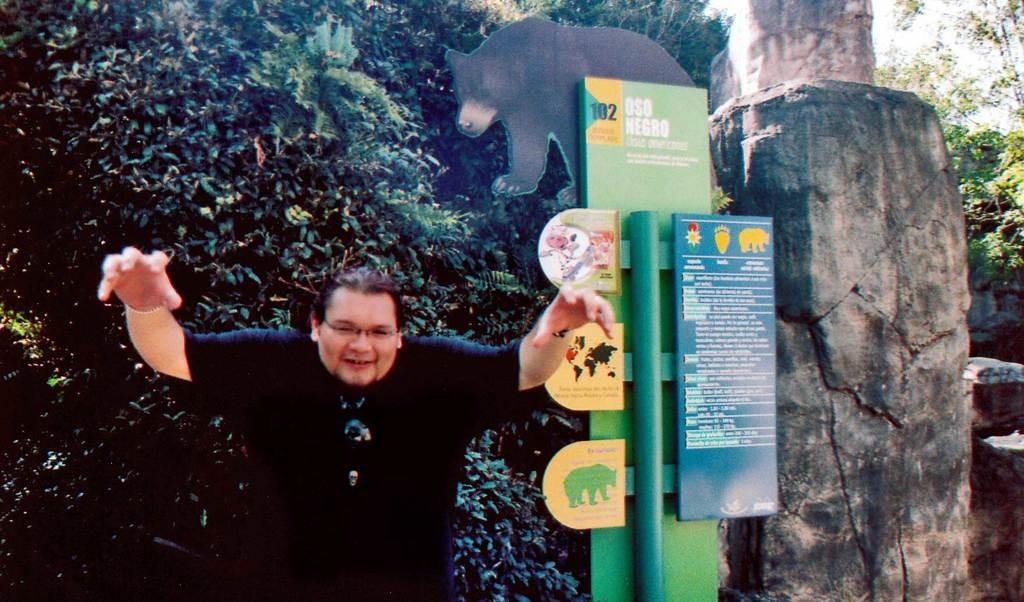Who or what is the main subject in the image? There is a person in the image. What is located behind the person? There is a board behind the person. What can be seen in the distance in the image? There are trees and rocks in the background of the image. What type of liquid can be seen spilling from the person's hands in the image? There is no liquid present in the image; the person's hands are not shown spilling anything. 